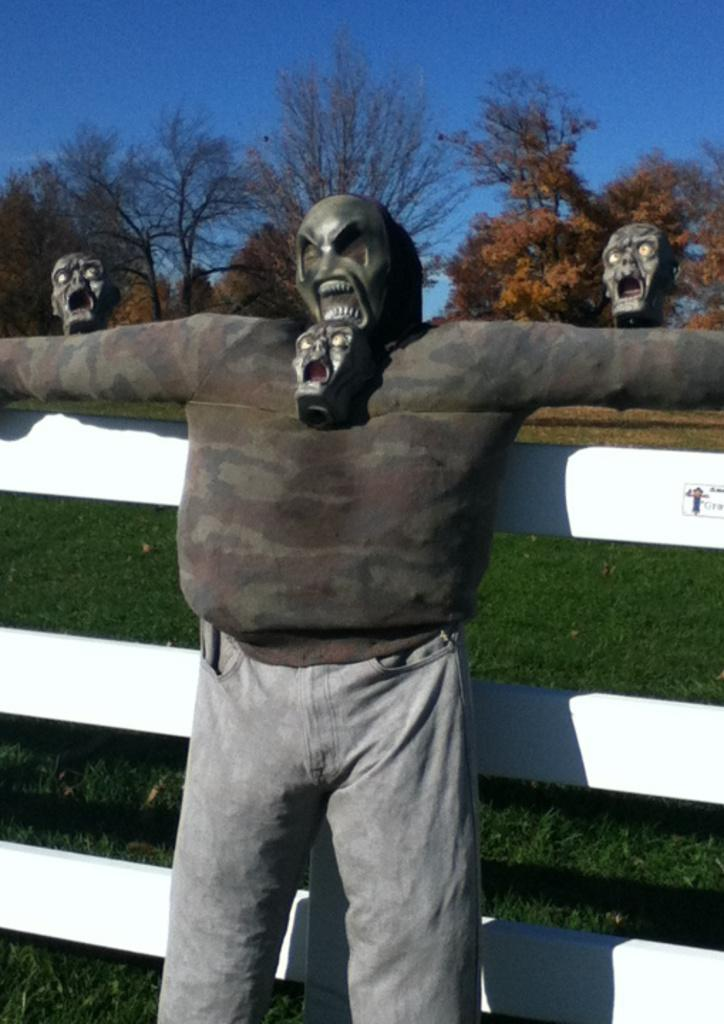What is the main subject in the center of the image? There is a scarecrow in the center of the image. What can be seen surrounding the scarecrow? There is a fence in the image. What type of accessories are present in the image? There are masks in the image. What type of natural environment is visible in the background? There are trees, grass, and the sky visible in the background of the image. How many feet does the scarecrow have in the image? The scarecrow does not have feet in the image; it is a stationary figure. What type of grain is being harvested in the image? There is no grain visible in the image; it only features a scarecrow, a fence, masks, and the natural environment in the background. 